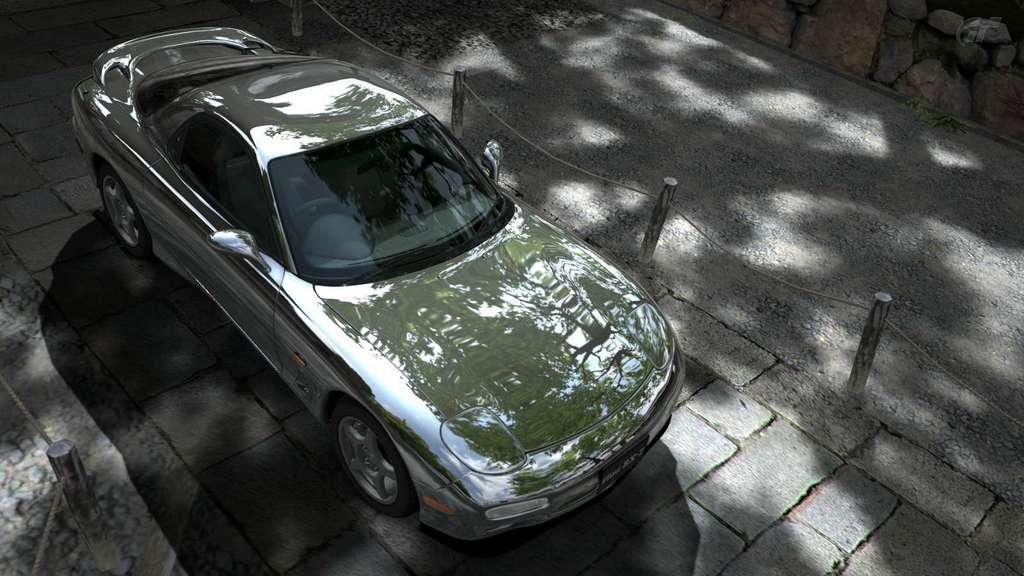Please provide a concise description of this image. In the center of the image we can see a car. In the background of the image we can see the barricades, road. In the top right corner we can see some rocks. 